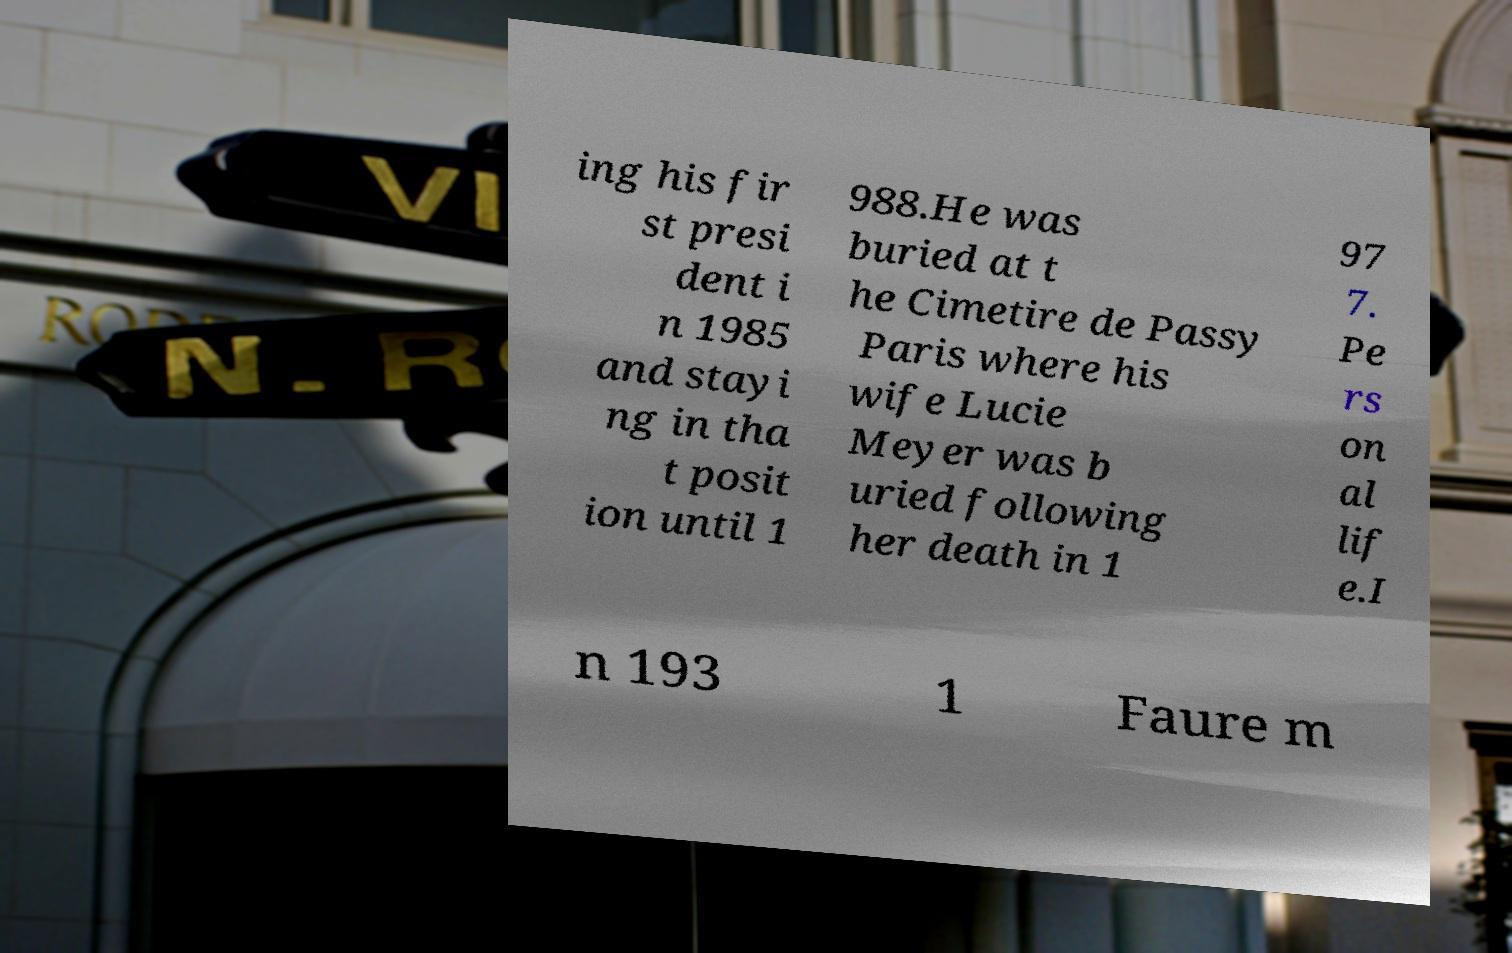For documentation purposes, I need the text within this image transcribed. Could you provide that? ing his fir st presi dent i n 1985 and stayi ng in tha t posit ion until 1 988.He was buried at t he Cimetire de Passy Paris where his wife Lucie Meyer was b uried following her death in 1 97 7. Pe rs on al lif e.I n 193 1 Faure m 